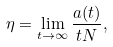<formula> <loc_0><loc_0><loc_500><loc_500>\eta = \lim _ { t \rightarrow \infty } \frac { a ( t ) } { t N } ,</formula> 